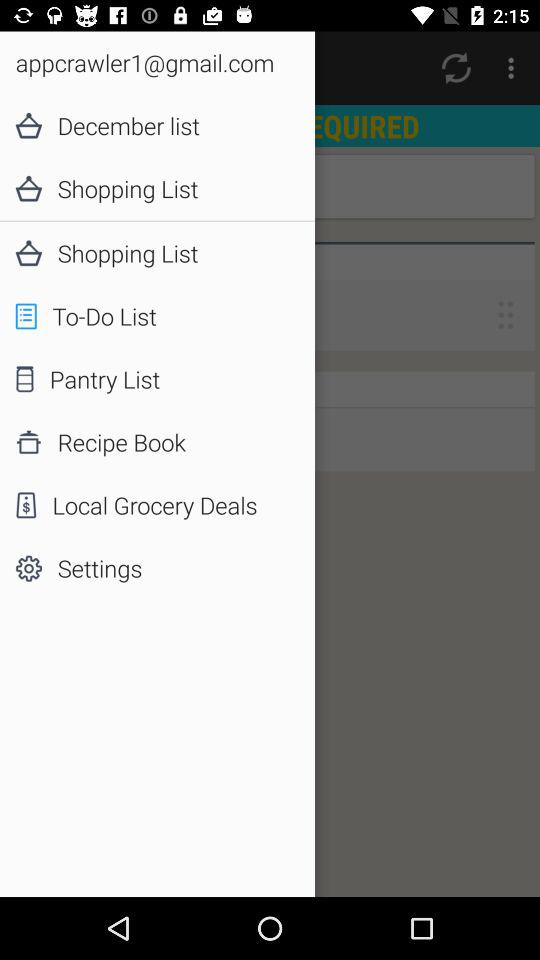What is the user's email address? The email address is appcrawler1@gmail.com. 